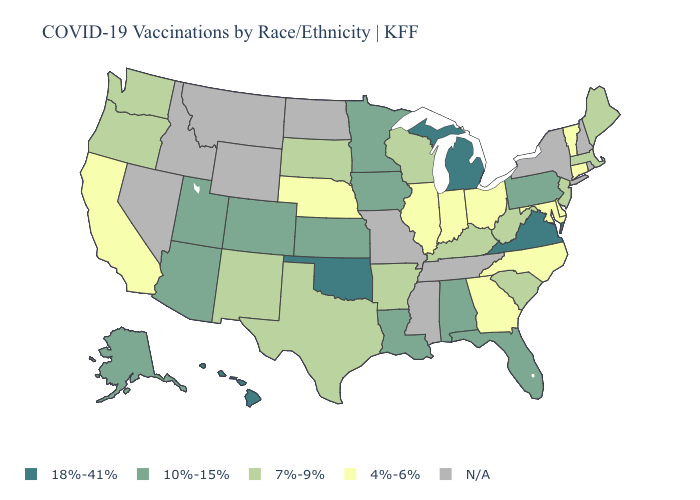What is the value of Michigan?
Quick response, please. 18%-41%. Name the states that have a value in the range 10%-15%?
Quick response, please. Alabama, Alaska, Arizona, Colorado, Florida, Iowa, Kansas, Louisiana, Minnesota, Pennsylvania, Utah. What is the value of Nevada?
Keep it brief. N/A. How many symbols are there in the legend?
Short answer required. 5. Among the states that border Virginia , does West Virginia have the lowest value?
Concise answer only. No. Does Kansas have the lowest value in the USA?
Be succinct. No. What is the value of Illinois?
Answer briefly. 4%-6%. What is the lowest value in the MidWest?
Write a very short answer. 4%-6%. What is the lowest value in the USA?
Write a very short answer. 4%-6%. Name the states that have a value in the range 18%-41%?
Keep it brief. Hawaii, Michigan, Oklahoma, Virginia. Name the states that have a value in the range 18%-41%?
Be succinct. Hawaii, Michigan, Oklahoma, Virginia. How many symbols are there in the legend?
Answer briefly. 5. What is the value of Alaska?
Answer briefly. 10%-15%. 